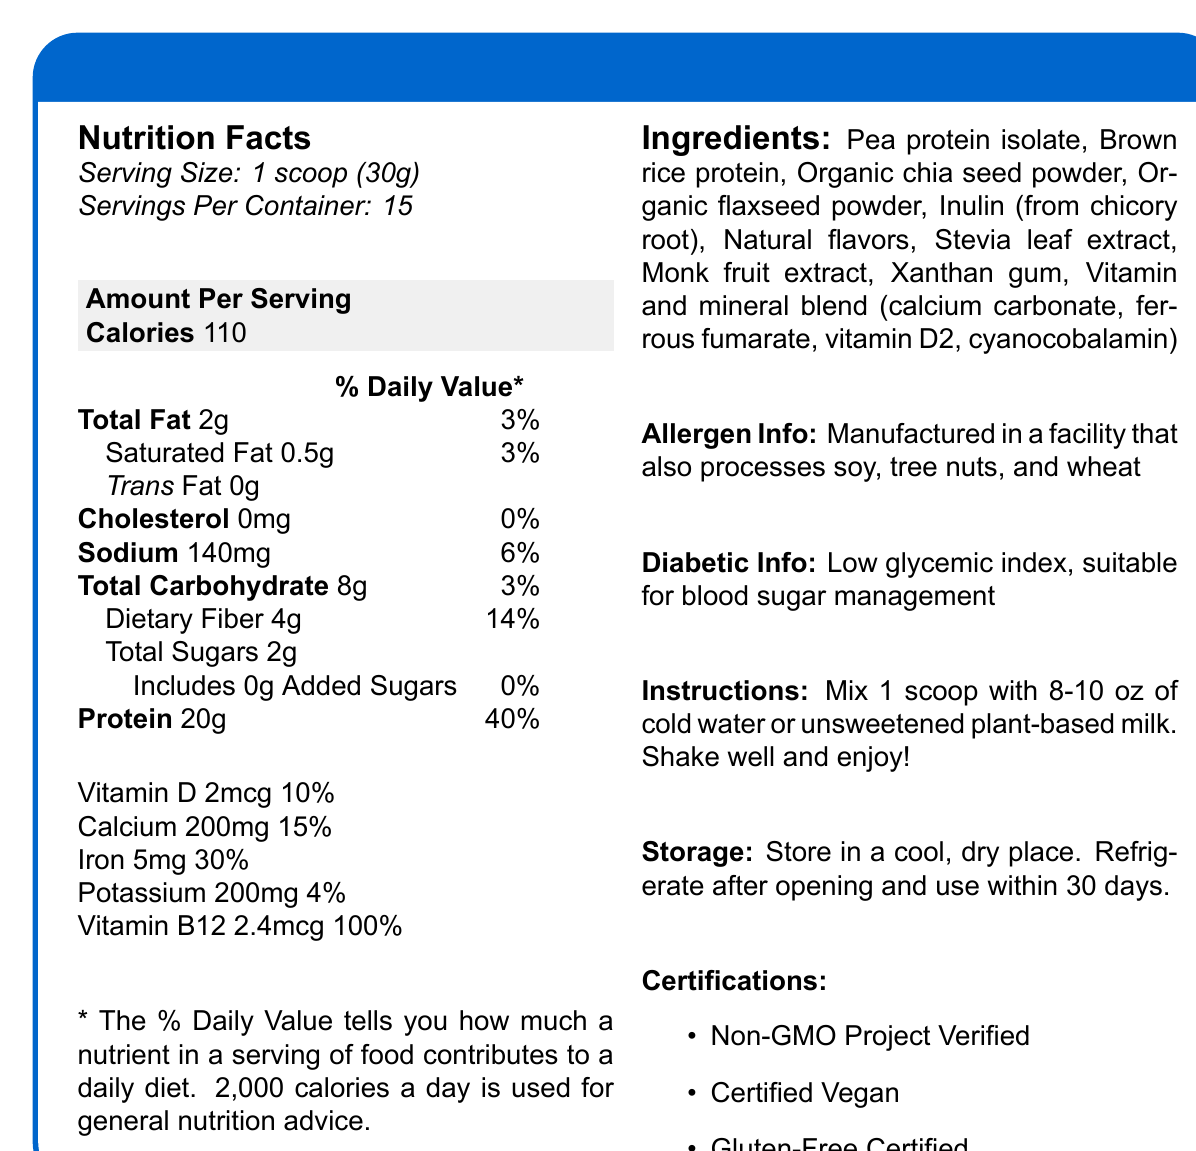what is the serving size? The serving size is stated at the top of the Nutrition Facts section as "Serving Size: 1 scoop (30g)".
Answer: 1 scoop (30g) how many calories are in one serving? The Nutrition Facts section lists the calories per serving as 110.
Answer: 110 how much protein does one serving contain? The Nutrition Facts section specifies that one serving contains 20g of protein.
Answer: 20g what is the amount of dietary fiber per serving? The amount of dietary fiber per serving is listed as 4g in the Total Carbohydrate section.
Answer: 4g is this product certified vegan? The certification section lists the product as "Certified Vegan".
Answer: Yes does the shake contain any added sugars? The Total Carbohydrate section specifies that the shake includes 0g added sugars.
Answer: No how much calcium is in one serving? The Nutrition Facts section lists the calcium content per serving as 200mg.
Answer: 200mg what ingredient is first listed in the ingredient list? Pea protein isolate is the first ingredient listed under the Ingredients section.
Answer: Pea protein isolate how should this product be stored after opening? The storage instructions state that it should be refrigerated after opening and used within 30 days.
Answer: Refrigerate after opening and use within 30 days which vitamins and minerals are included in the shake? A. Vitamin C, Vitamin D, Calcium B. Vitamin D, Calcium, Iron, Vitamin B12 C. Vitamins A, K, B6, C The Nutrition Facts section lists Vitamin D, Calcium, Iron, and Vitamin B12 with their respective values.
Answer: B. Vitamin D, Calcium, Iron, Vitamin B12 what is the percentage of the daily value for iron provided by one serving? A. 10% B. 15% C. 30% D. 45% The Nutrition Facts section states that one serving provides 30% of the daily value for iron.
Answer: C. 30% is the DiaBeet Balance Plant Protein Shake gluten-free? The certification section indicates that the product is "Gluten-Free Certified".
Answer: Yes does the label mention if the shake is suitable for blood sugar management? The label has a Diabetic Info section stating "Low glycemic index, suitable for blood sugar management".
Answer: Yes summarize the main points covered in the DiaBeet Balance Plant Protein Shake nutrition label. The document lists the nutritional information, certifications, ingredients, diabetic suitability, instructions for usage and storage, and allergen information for the DiaBeet Balance Plant Protein Shake. It is designed for those with diabetes and contains beneficial nutrients like protein and fiber.
Answer: The DiaBeet Balance Plant Protein Shake is designed for individuals with diabetes, offering 110 calories per serving with 20g of protein, 4g of dietary fiber, and 2g of sugar. It is low in fat, has no added sugars, and has beneficial vitamins and minerals such as Vitamin D, Calcium, Iron, and Vitamin B12. Ingredients include plant-based proteins and natural sweeteners. The product is certified non-GMO, vegan, and gluten-free, and is manufactured in a facility that processes multiple allergens. It has a low glycemic index, suitable for blood sugar management. Mixing and storage instructions are also provided. what is the source of sweetness in the shake? The Ingredients section lists Stevia leaf extract and Monk fruit extract as sources of sweetness.
Answer: Stevia leaf extract and Monk fruit extract when was this product manufactured? The document does not provide any information about the manufacturing date.
Answer: Not enough information how many servings are in one container? The Serving Size information states that there are 15 servings per container.
Answer: 15 what amount of sodium is in one serving? The Nutrition Facts section lists the sodium content per serving as 140mg.
Answer: 140mg 